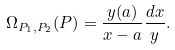<formula> <loc_0><loc_0><loc_500><loc_500>\Omega _ { P _ { 1 } , P _ { 2 } } ( P ) = \frac { y ( a ) } { x - a } \frac { d x } { y } .</formula> 